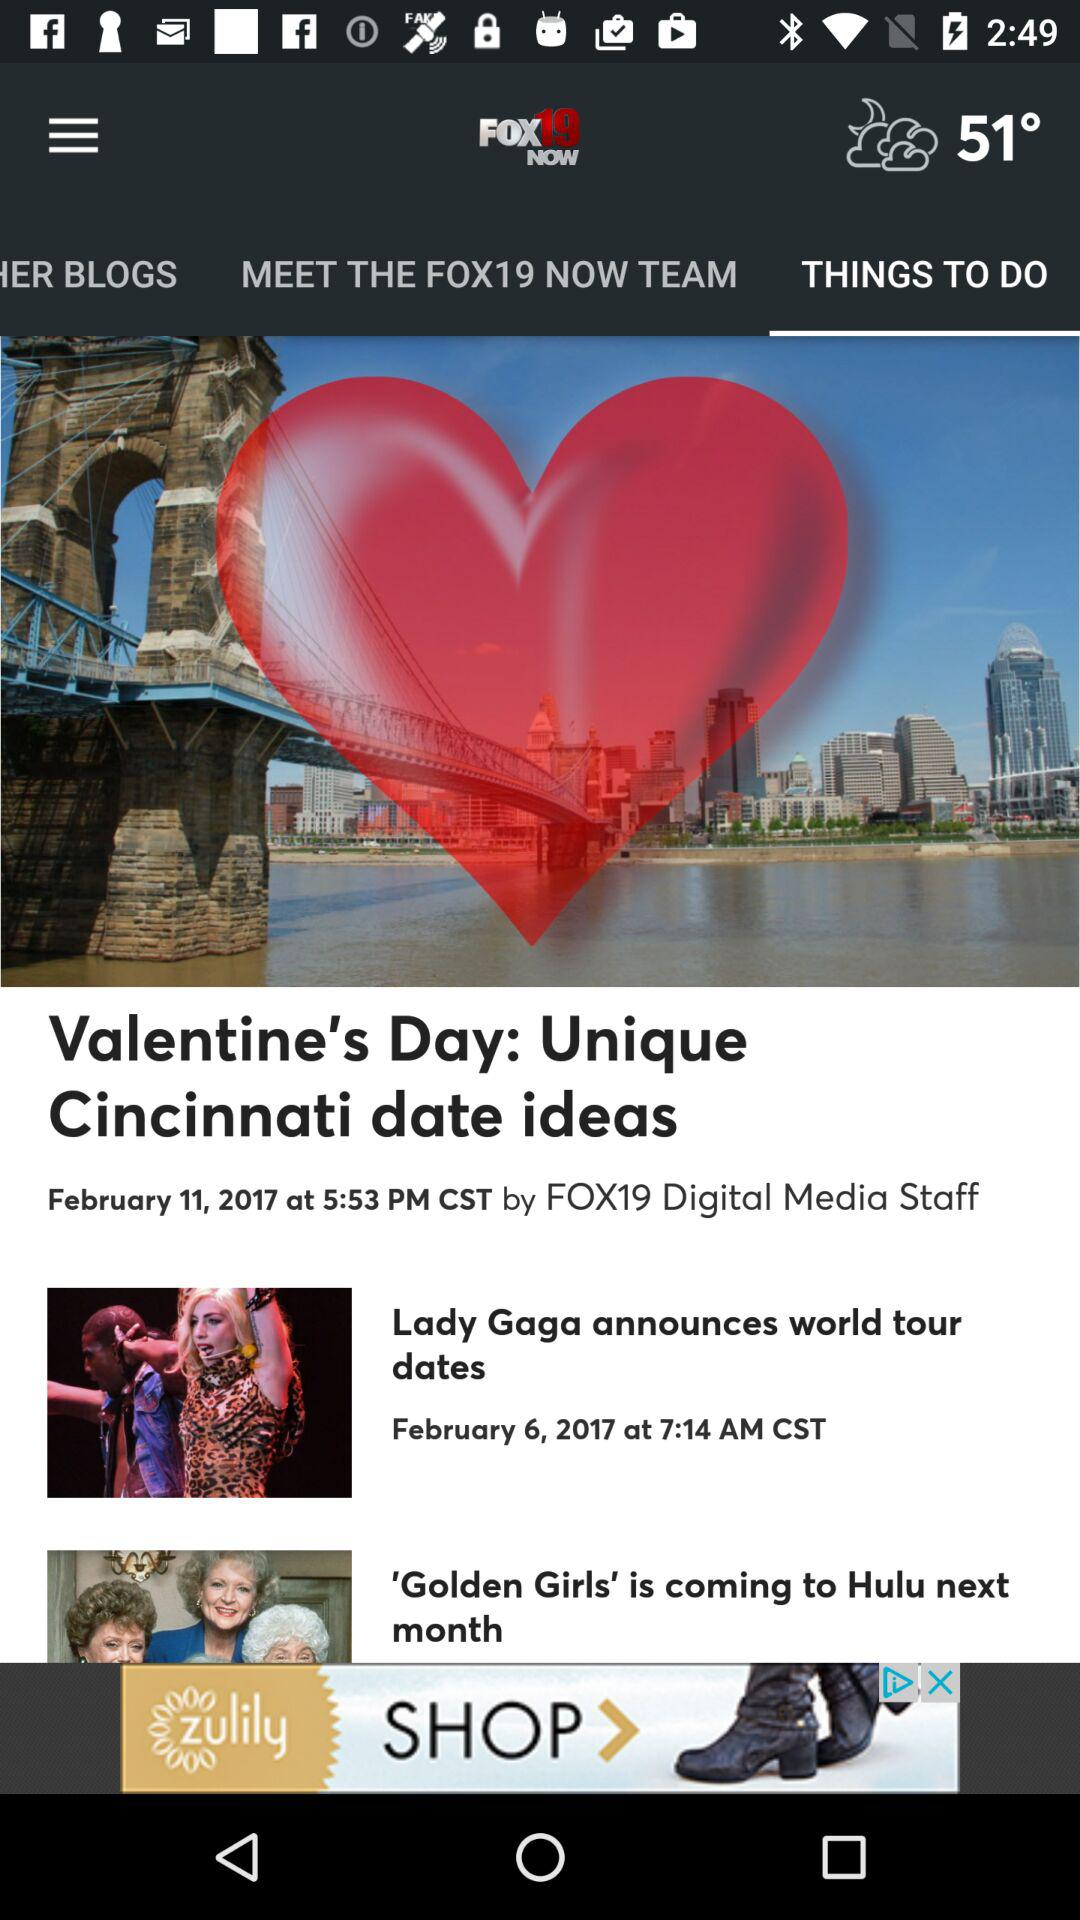What is the posted date and time of "Valentine's Day: Unique Cincinnati date ideas"? The posted date and time are February 11, 2017 and 5:53 PM, respectively. 